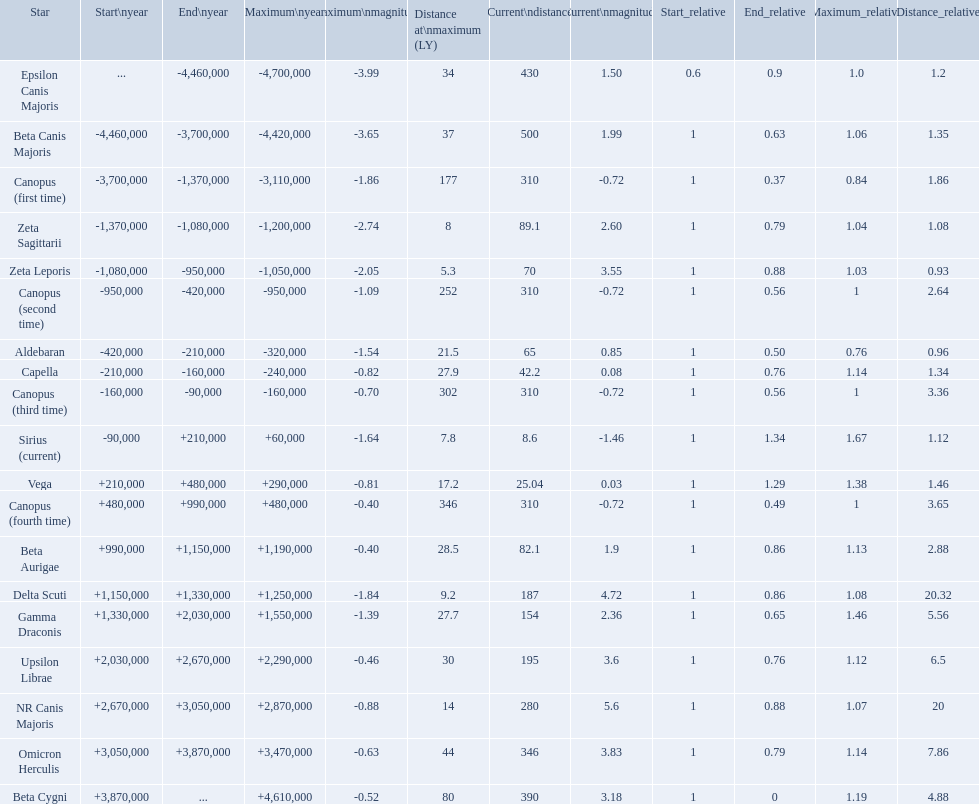What are the historical brightest stars? Epsilon Canis Majoris, Beta Canis Majoris, Canopus (first time), Zeta Sagittarii, Zeta Leporis, Canopus (second time), Aldebaran, Capella, Canopus (third time), Sirius (current), Vega, Canopus (fourth time), Beta Aurigae, Delta Scuti, Gamma Draconis, Upsilon Librae, NR Canis Majoris, Omicron Herculis, Beta Cygni. Of those which star has a distance at maximum of 80 Beta Cygni. 